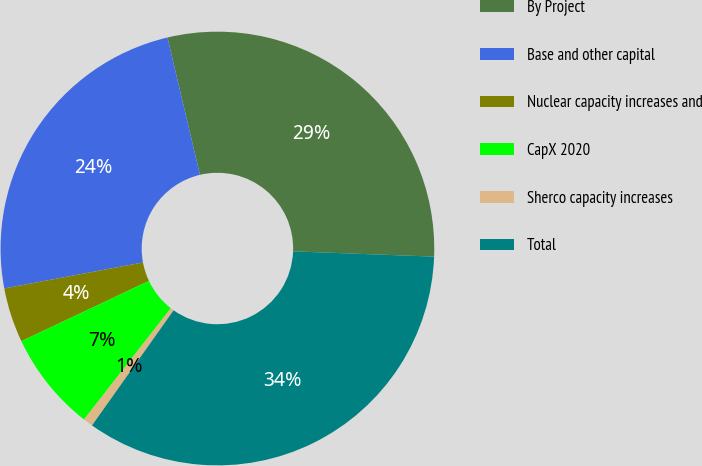Convert chart to OTSL. <chart><loc_0><loc_0><loc_500><loc_500><pie_chart><fcel>By Project<fcel>Base and other capital<fcel>Nuclear capacity increases and<fcel>CapX 2020<fcel>Sherco capacity increases<fcel>Total<nl><fcel>29.3%<fcel>24.25%<fcel>4.08%<fcel>7.43%<fcel>0.73%<fcel>34.22%<nl></chart> 